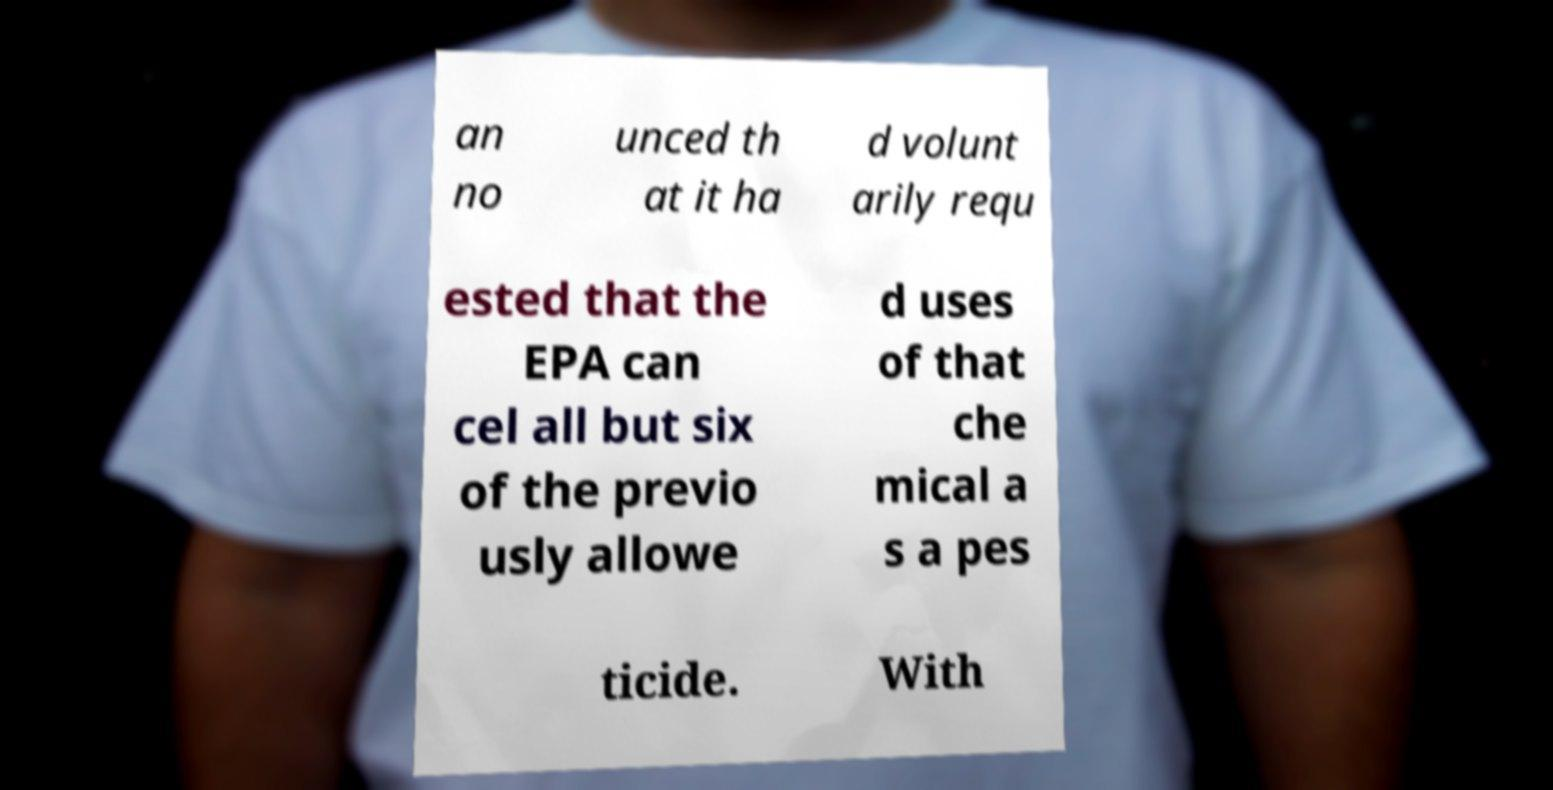Could you assist in decoding the text presented in this image and type it out clearly? an no unced th at it ha d volunt arily requ ested that the EPA can cel all but six of the previo usly allowe d uses of that che mical a s a pes ticide. With 